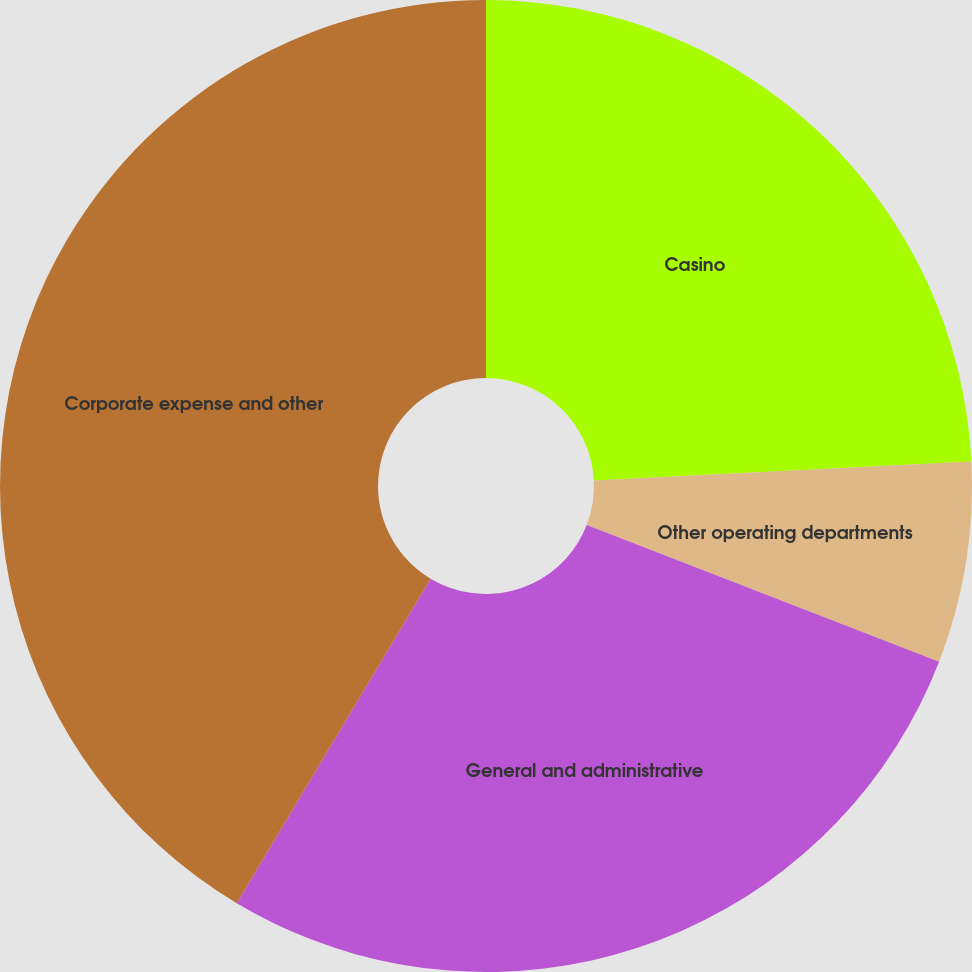<chart> <loc_0><loc_0><loc_500><loc_500><pie_chart><fcel>Casino<fcel>Other operating departments<fcel>General and administrative<fcel>Corporate expense and other<nl><fcel>24.2%<fcel>6.69%<fcel>27.68%<fcel>41.43%<nl></chart> 